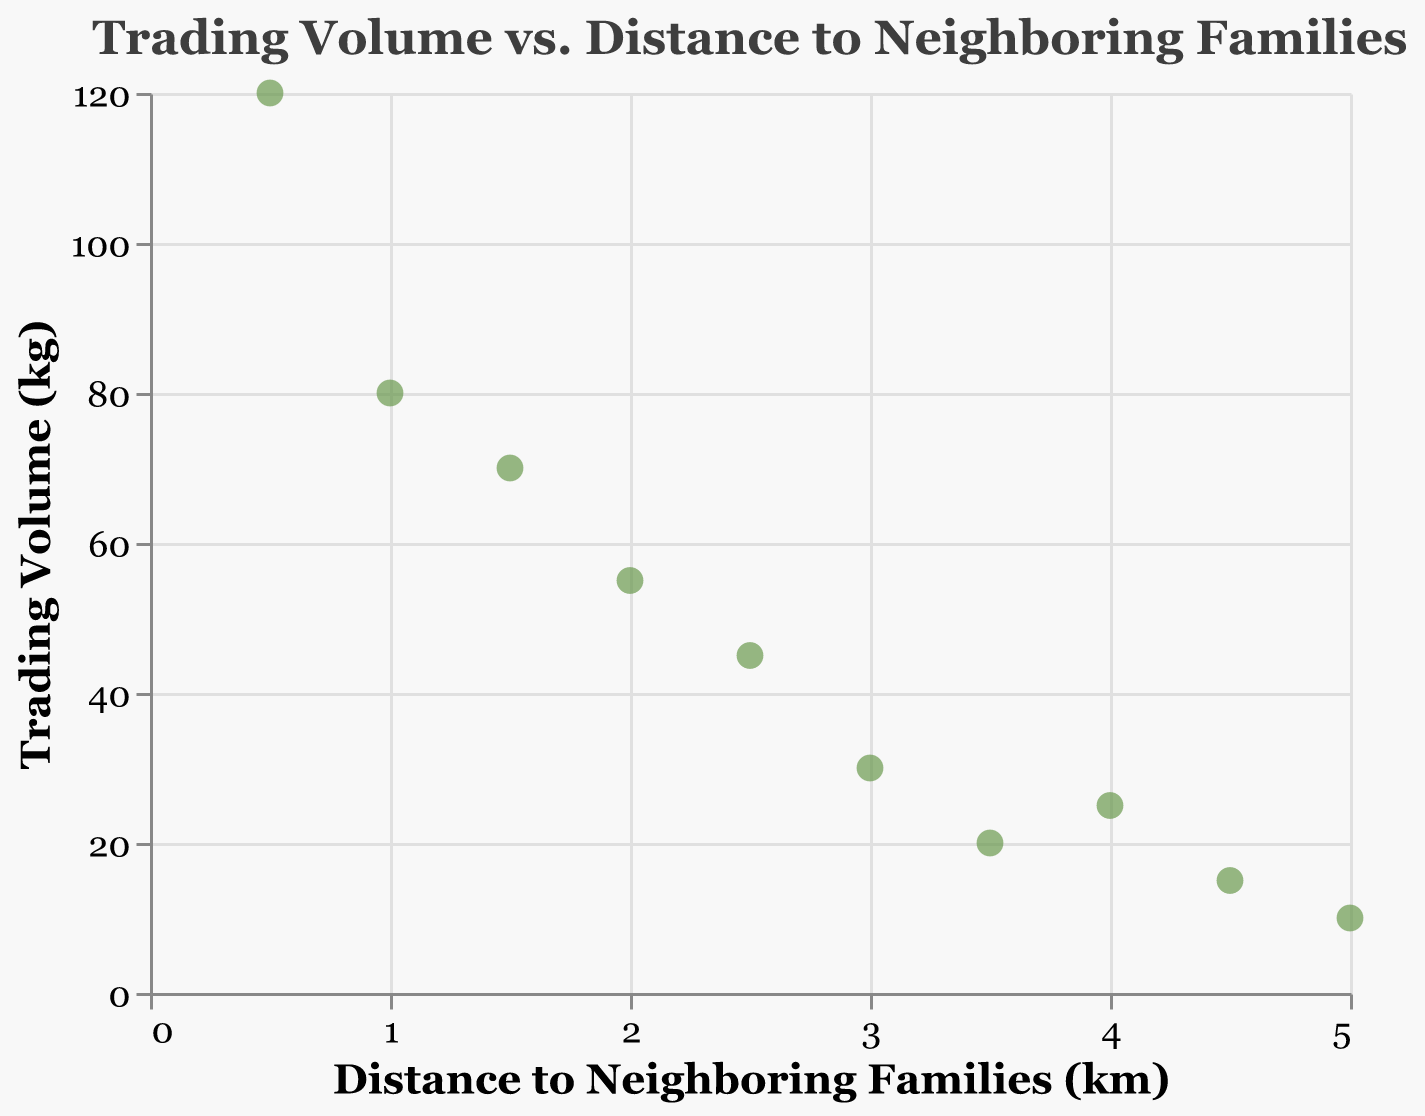How many data points are plotted in the figure? Count the number of circles (or data points) on the plot. Each one represents a data point. There are 10 data points visible.
Answer: 10 What is the relationship between trading volume and distance to neighboring families? Observe the trend of the data points. As the distance to neighboring families increases, the trading volume tends to decrease.
Answer: Trading volume decreases as distance increases What is the trading volume at a distance of 2.0 km? Locate the data point where the distance is 2.0 km on the x-axis and read the corresponding value on the y-axis. The trading volume at this distance is 55 kg.
Answer: 55 kg Compare the trading volumes at distances of 3.0 km and 4.0 km. Which one is higher? Check the y-values of the data points at these distances. Trading volume at 3.0 km is 30 kg, and at 4.0 km it is 25 kg. The trading volume at 3.0 km is higher.
Answer: 3.0 km What's the average trading volume shown in the figure? Sum all the trading volumes and divide by the number of data points: (120 + 80 + 70 + 55 + 45 + 30 + 20 + 25 + 15 + 10) / 10 = 47 kg.
Answer: 47 kg At what distance is the trading volume the highest? Identify the data point with the highest y-value. The trading volume is highest at 0.5 km with 120 kg.
Answer: 0.5 km What's the total trading volume for all distances greater than 3.0 km? Sum the trading volumes for distances greater than 3.0 km (3.5 km, 4.0 km, 4.5 km, and 5.0 km). The total is 20 + 25 + 15 + 10 = 70 kg.
Answer: 70 kg Does the plot indicate any outliers or anomalies in trading volume as distance increases? Observe the scatter plot for any data points that deviate significantly from the trend. The data point at 4.0 km (25 kg) seems slightly higher than the trend but isn't a significant outlier.
Answer: No significant outliers What is the distance with the lowest trading volume, and what is that volume? Identify the data point with the lowest y-value. The lowest trading volume is 10 kg at a distance of 5.0 km.
Answer: 5.0 km, 10 kg How does the trading volume change from a distance of 1.0 km to 1.5 km? Find the difference in trading volume between these distances. The trading volume decreases from 80 kg to 70 kg, a decrease of 10 kg.
Answer: Decreases by 10 kg 